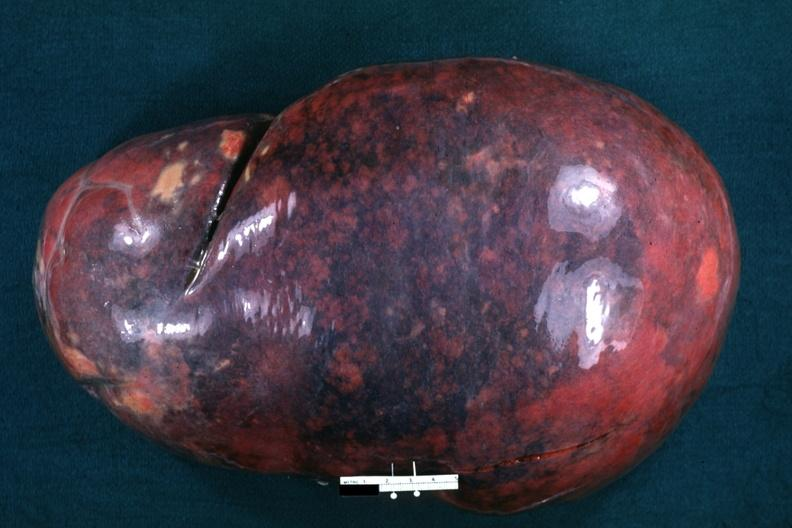does metastatic carcinoma oat cell show whole spleen massively enlarged?
Answer the question using a single word or phrase. No 